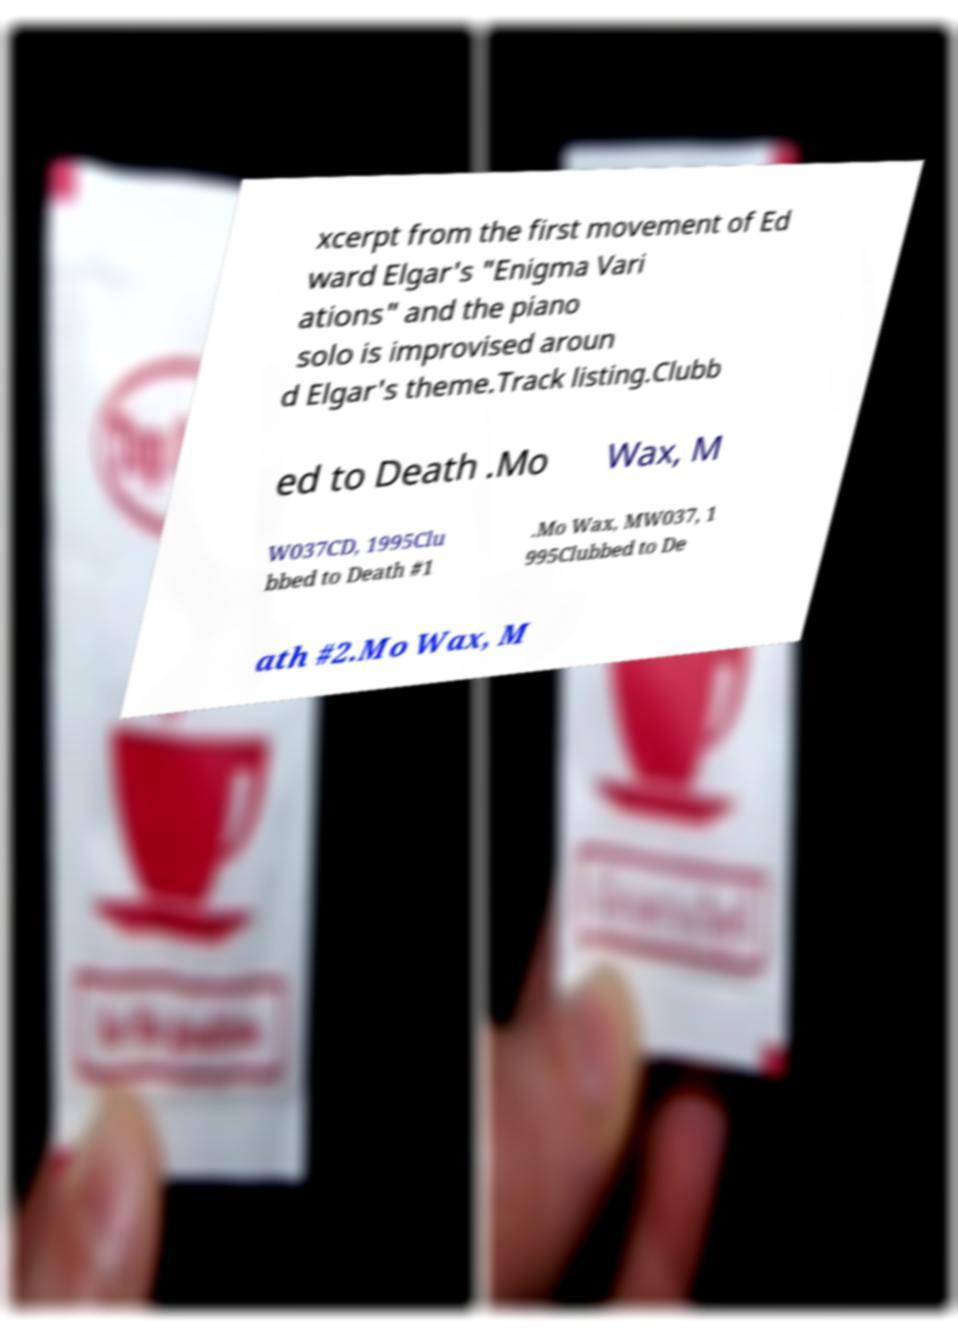Please read and relay the text visible in this image. What does it say? xcerpt from the first movement of Ed ward Elgar's "Enigma Vari ations" and the piano solo is improvised aroun d Elgar's theme.Track listing.Clubb ed to Death .Mo Wax, M W037CD, 1995Clu bbed to Death #1 .Mo Wax, MW037, 1 995Clubbed to De ath #2.Mo Wax, M 